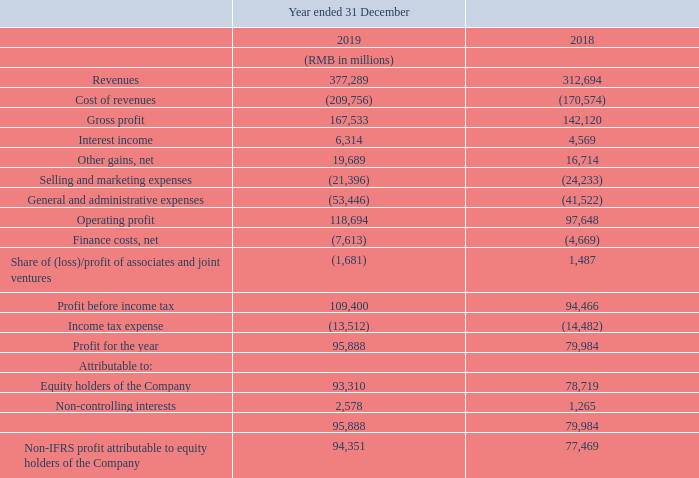Other gains, net. We recorded net other gains totalling RMB19,689 million for the year ended 31 December 2019, which primarily comprised of non-IFRS adjustment items such as fair value gains arising from increased valuations for certain investee companies in verticals such as FinTech services, social media and education, as well as net deemed disposal gains arising from the capital activities of certain investee companies in verticals including transportation services and online games.
Selling and marketing expenses. Selling and marketing expenses decreased by 12% to RMB21,396 million for the year ended 31 December 2019 on a year-on-year basis. The decrease was mainly due to the reduction of advertising and promotion expenses as a result of improved operational efficiencies. As a percentage of revenues, selling and marketing expenses decreased to 6% for the year ended 31 December 2019 from 8% for the year ended 31 December 2018.
General and administrative expenses. General and administrative expenses increased by 29% to RMB53,446 million for the year ended 31 December 2019 on a year-on-year basis. The increase was primarily driven by greater R&D expenses and staff costs. As a percentage of revenues, general and administrative expenses increased to 14% for the year ended 31 December 2019 from 13% for the year ended 31 December 2018.
Finance costs, net. Net finance costs increased by 63% to RMB7,613 million for the year ended 31 December 2019 on a year-on-year basis. The increase primarily reflected greater interest expenses resulting from higher amounts of indebtedness.
Share of (loss)/profit of associates and joint ventures. We recorded share of losses of associates and joint ventures of RMB1,681 million for the year ended 31 December 2019, compared to share of profit of RMB1,487 million for the year ended 31 December 2018. The change was mainly due to non-cash charges booked by certain associates.
Income tax expense. Income tax expense decreased by 7% to RMB13,512 million for the year ended 31 December 2019 on a year-on-year basis. The decrease mainly reflected the entitlements of preferential tax treatments and benefits.
Profit attributable to equity holders of the Company. Profit attributable to equity holders of the Company increased by 19% to RMB93,310 million for the year ended 31 December 2019 on a year-on-year basis. Non-IFRS profit attributable to equity holders of the Company increased by 22% to RMB94,351 million for the year ended 31 December 2019.
What was the 2019 profit margin?
Answer scale should be: percent. 95,888/377,289
Answer: 25.42. What was the 2018 profit margin?
Answer scale should be: percent. 79,984/312,694
Answer: 25.58. For 2019, what percentage of revenue is cost of revenue?
Answer scale should be: percent. 209,756/377,289
Answer: 55.6. What is the 2019 percentage change in selling & marketing expenses? 12%. What was the reason for the 2019 year-on-year percentage change in selling and marketing expenses? The decrease was mainly due to the reduction of advertising and promotion expenses as a result of improved operational efficiencies. What was the reason behind the increase in the 2019 general and administrative expenses? The increase was primarily driven by greater r&d expenses and staff costs. 